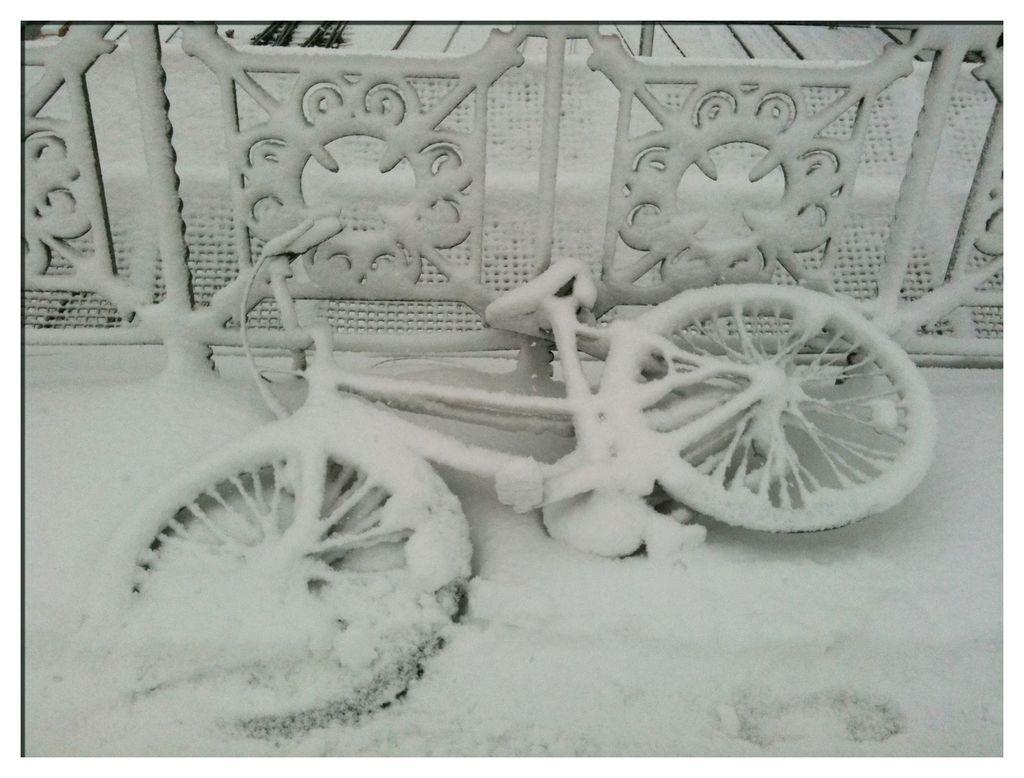Could you give a brief overview of what you see in this image? In this image we can see a bicycle and also the railing which is fully covered with the snow. 